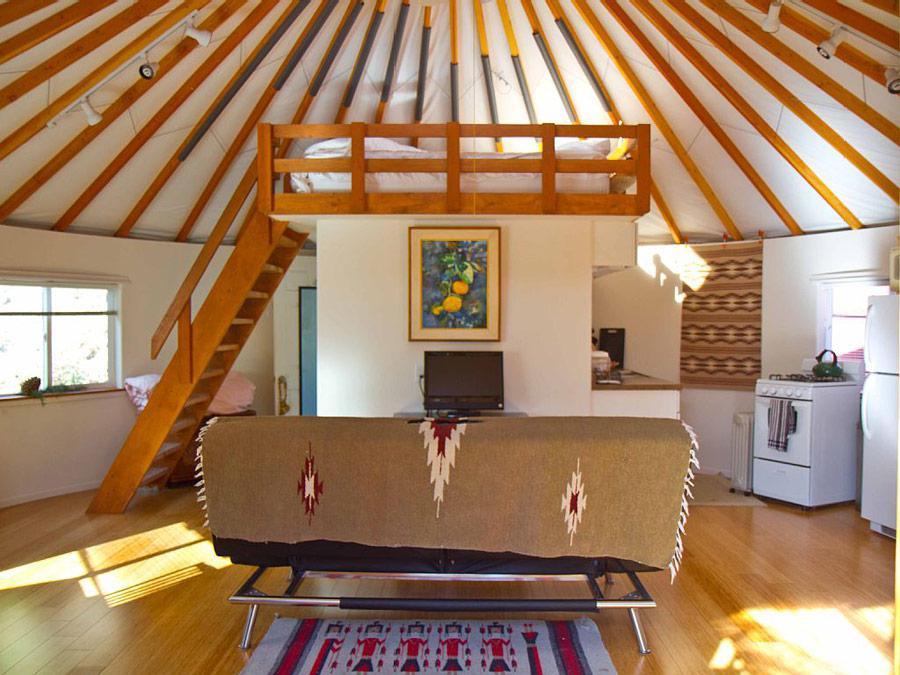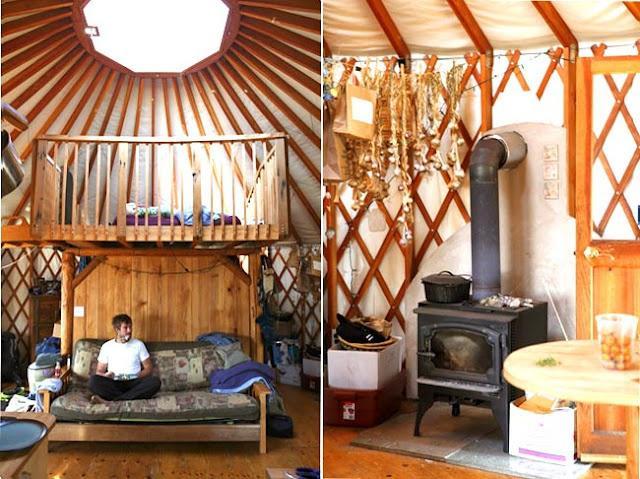The first image is the image on the left, the second image is the image on the right. Evaluate the accuracy of this statement regarding the images: "A painting hangs on the wall in the image on the right.". Is it true? Answer yes or no. No. The first image is the image on the left, the second image is the image on the right. For the images shown, is this caption "Left image shows a camera-facing ladder in front of a loft area with a railing of vertical posts." true? Answer yes or no. No. 